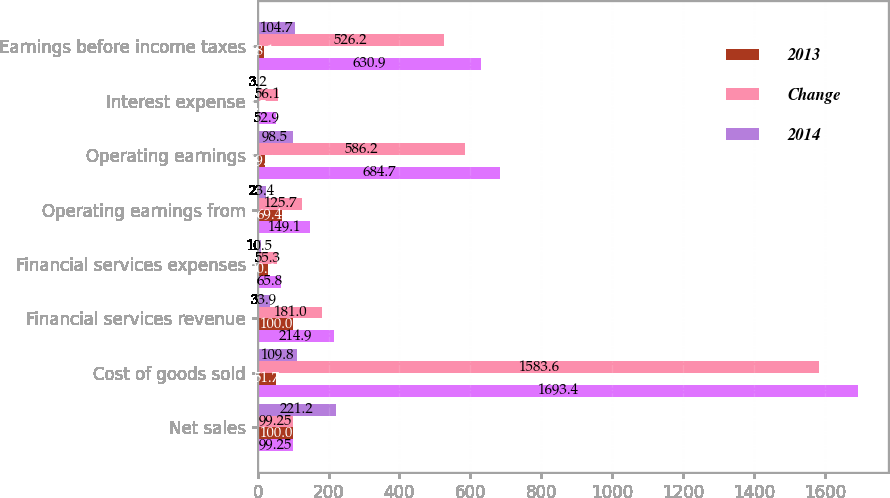Convert chart. <chart><loc_0><loc_0><loc_500><loc_500><stacked_bar_chart><ecel><fcel>Net sales<fcel>Cost of goods sold<fcel>Financial services revenue<fcel>Financial services expenses<fcel>Operating earnings from<fcel>Operating earnings<fcel>Interest expense<fcel>Earnings before income taxes<nl><fcel>nan<fcel>99.25<fcel>1693.4<fcel>214.9<fcel>65.8<fcel>149.1<fcel>684.7<fcel>52.9<fcel>630.9<nl><fcel>2013<fcel>100<fcel>51.7<fcel>100<fcel>30.6<fcel>69.4<fcel>19.6<fcel>1.5<fcel>18.1<nl><fcel>Change<fcel>99.25<fcel>1583.6<fcel>181<fcel>55.3<fcel>125.7<fcel>586.2<fcel>56.1<fcel>526.2<nl><fcel>2014<fcel>221.2<fcel>109.8<fcel>33.9<fcel>10.5<fcel>23.4<fcel>98.5<fcel>3.2<fcel>104.7<nl></chart> 